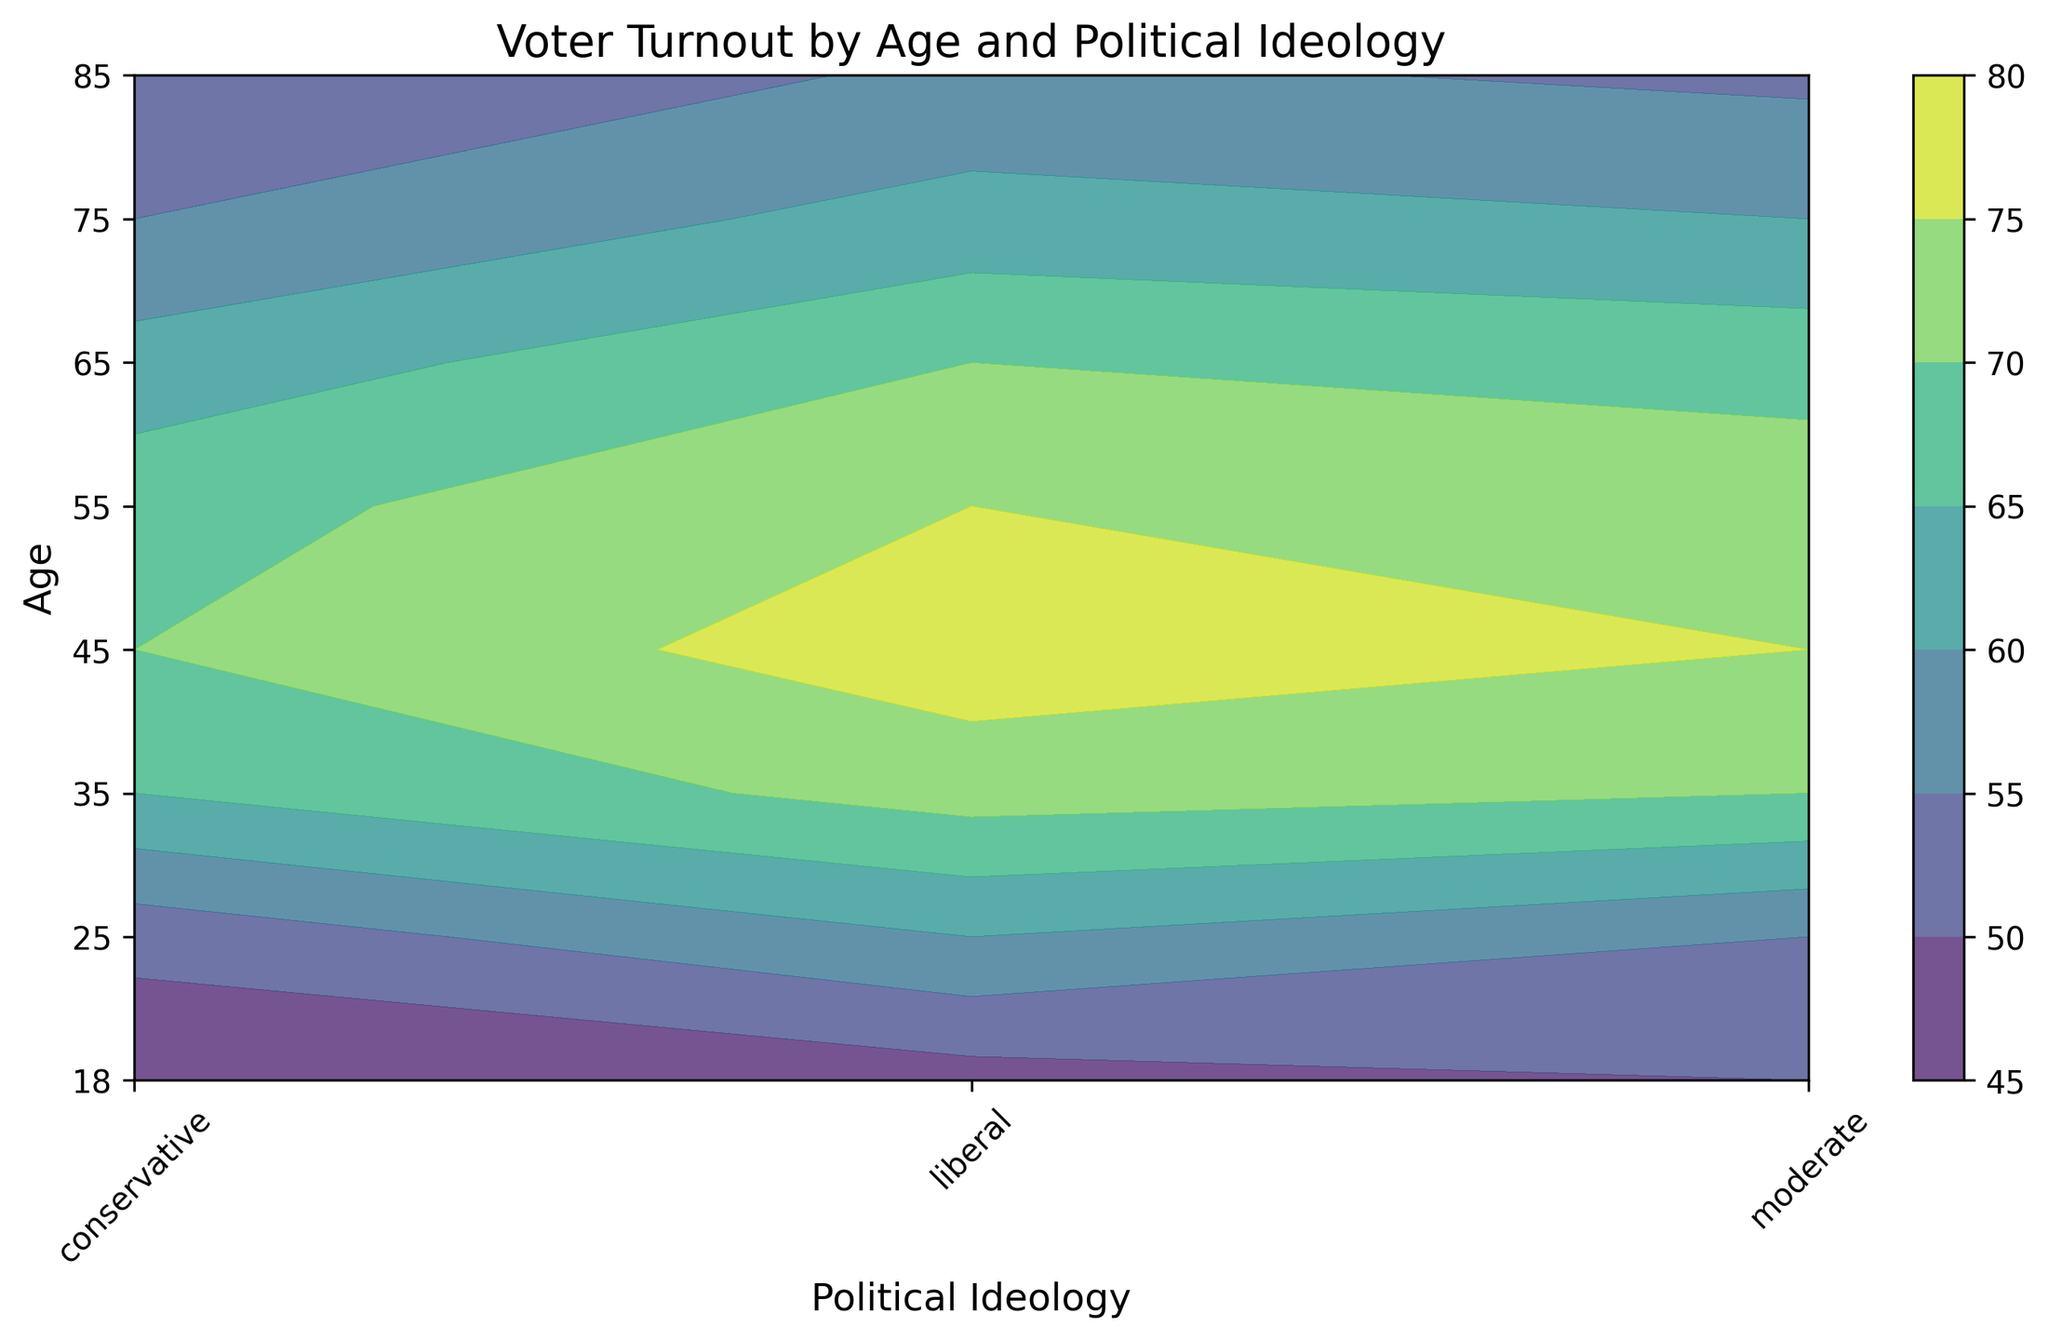what are the voter turnout percentage ranges for conservatives across all age groups? To determine the voter turnout percentage ranges for conservatives across all age groups, look at the contour plot and focus on the 'conservative' ideology column. Identify the minimum and maximum percentages shown.
Answer: 45% to 70% How does voter turnout at age 25 compare between moderates and liberals? To compare the voter turnout at age 25 between moderates and liberals, locate the age 25 row and compare the heights (color intensity) of the points corresponding to moderate and liberal ideologies.
Answer: 55% (moderate) vs. 60% (liberal) Which political ideology has the highest voter turnout among individuals aged 35? Locate the age 35 row, and identify the highest value across the three ideologies (conservative, moderate, liberal). The point with the highest color intensity indicates the ideology with the highest turnout.
Answer: liberal What is the average voter turnout for liberal individuals aged 55 and 65? To find the average voter turnout for liberal individuals aged 55 and 65, find the turnout percentages for these ages in the liberal column, sum them up, and divide by 2. The values are 75 and 70, so (75+70) / 2 = 72.5
Answer: 72.5% At which age does the voter turnout for conservatives peak? To find the age where conservative voter turnout peaks, identify the age with the highest color intensity in the conservative column.
Answer: 45 Which age group shows the steepest decline in voter turnout for conservatives? To identify the steepest decline in voter turnout for conservatives, compare voter turnout percentages as you move across age groups for the 'conservative' ideology column. Find the age group with the largest negative difference.
Answer: 55 to 65 Is there a clear trend in voter turnout among different age groups for liberals? To determine if there’s a trend, visually inspect the ‘liberal’ ideology column from bottom to top. Observe if the voter turnout increases, decreases, or stays the same.
Answer: decreases How does voter turnout for individuals aged 75 compare across ideologies? To compare voter turnout, locate the age 75 row and examine the values for conservative, moderate, and liberal ideologies. Compare the heights (color intensities) visually.
Answer: 55% (conservative), 60% (moderate), 62% (liberal) What is the difference in voter turnout between the youngest and oldest groups for moderates? Subtract the voter turnout value at age 18 from the value at age 85 in the moderate column. The values are 50 and 54 respectively, so 54 - 50 = 4.
Answer: 4% Which ideology shows the least variation in voter turnout across all ages? To identify the ideology with the least variation, visually assess the consistency of colors across each ideology column. The ideology with the most uniform color intensity shows the least variation.
Answer: moderate 